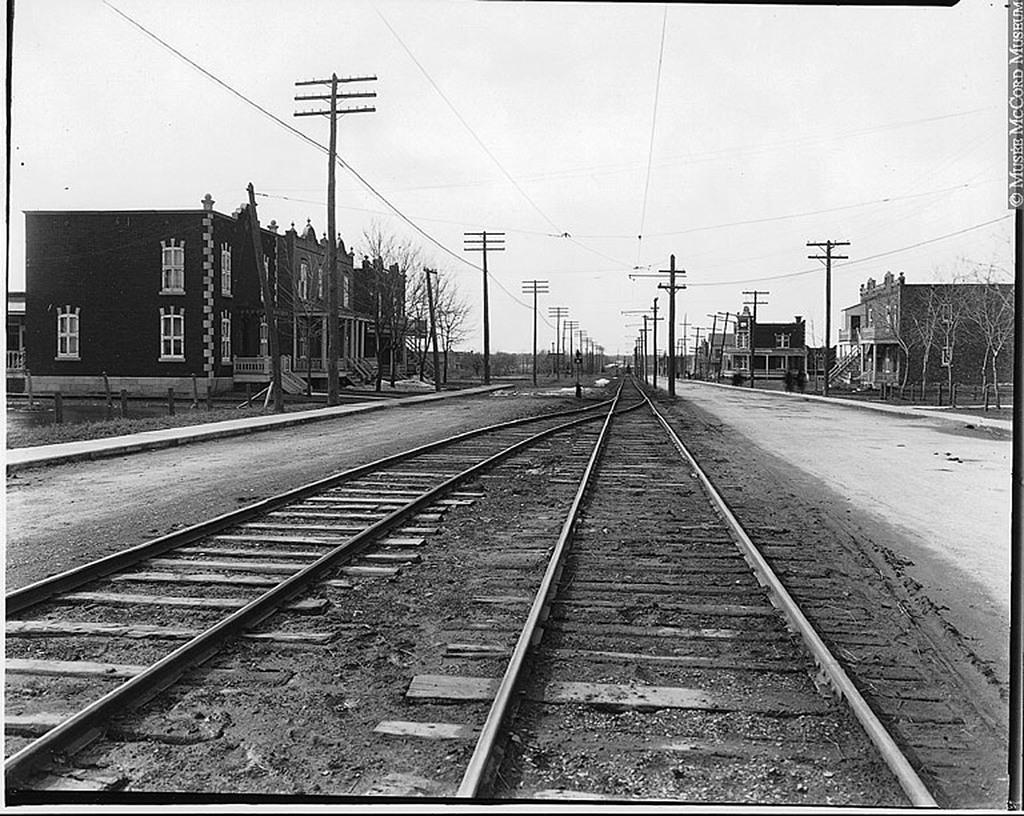In one or two sentences, can you explain what this image depicts? In this picture I can observe two railway tracks in the middle of the picture. On either sides of the picture I can observe buildings. In the background there is sky. 